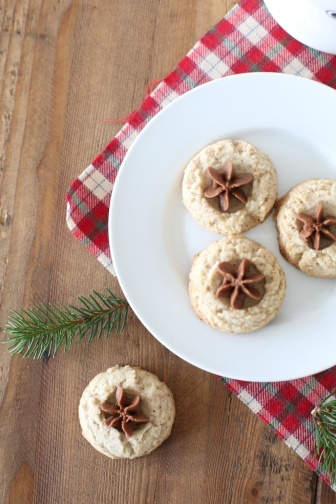Could you write a very creative and whimsical poem about the scene? In a cozy kitchen, warm delights,
Sugar cookies take their flight.
Each adorned with an anise star,
Glistening softly from afar.
On a napkin, red and white,
They spread their festive, sweet invite.
Greenery whispers tales of yore,
Of holidays and joy in store.
Oh, how they beckon, soft and sweet,
A treat for hearts when loved ones meet. 